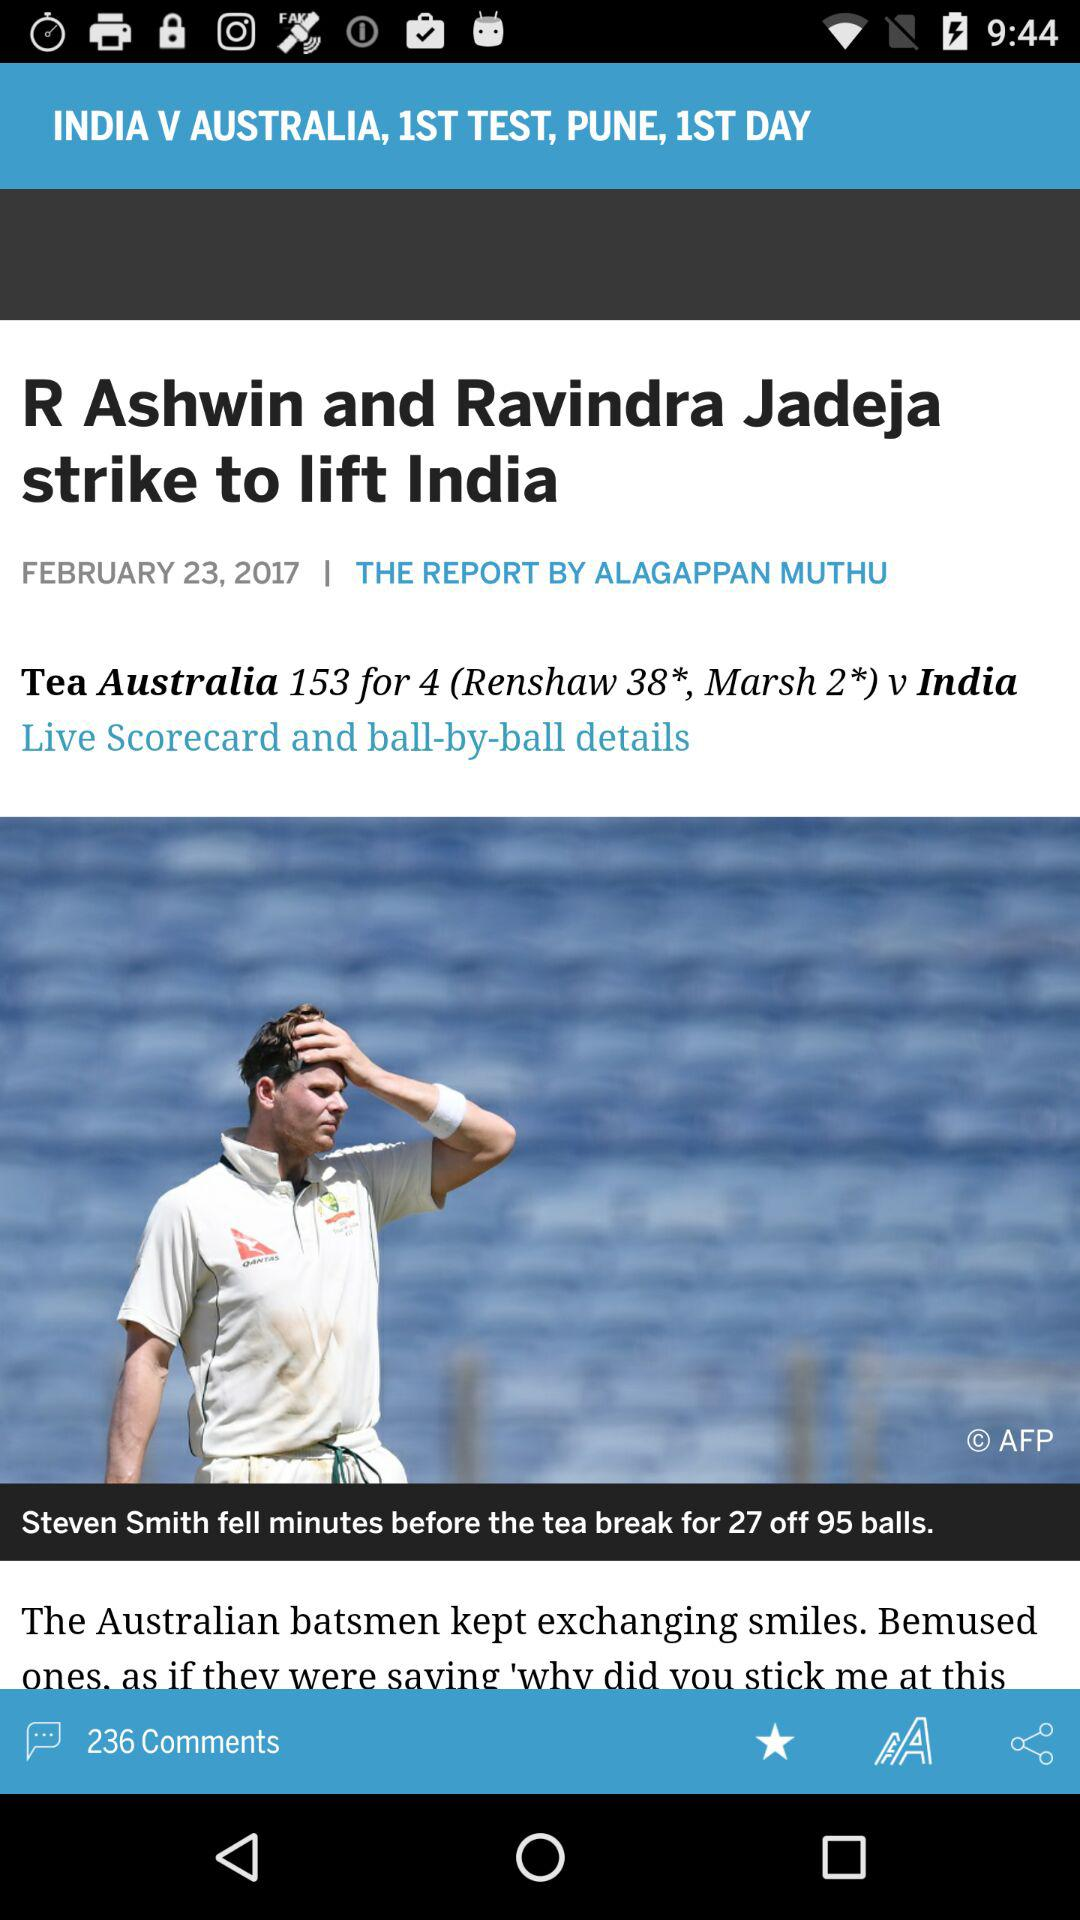How many comments are there? There are 236 comments. 